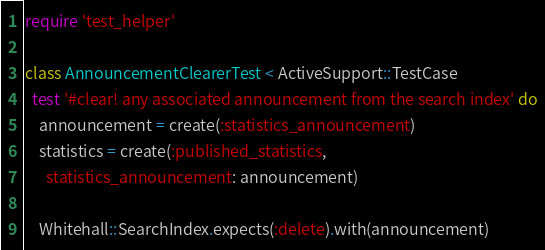<code> <loc_0><loc_0><loc_500><loc_500><_Ruby_>require 'test_helper'

class AnnouncementClearerTest < ActiveSupport::TestCase
  test '#clear! any associated announcement from the search index' do
    announcement = create(:statistics_announcement)
    statistics = create(:published_statistics,
      statistics_announcement: announcement)

    Whitehall::SearchIndex.expects(:delete).with(announcement)</code> 